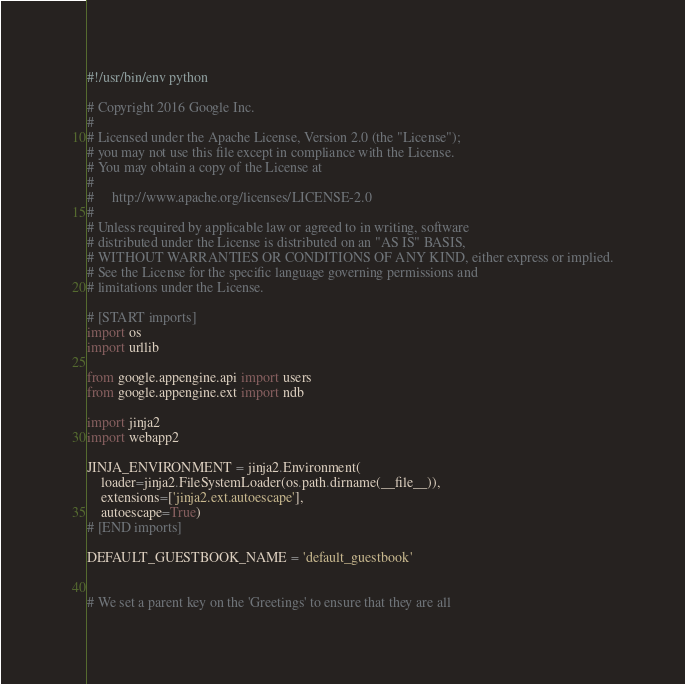Convert code to text. <code><loc_0><loc_0><loc_500><loc_500><_Python_>#!/usr/bin/env python

# Copyright 2016 Google Inc.
#
# Licensed under the Apache License, Version 2.0 (the "License");
# you may not use this file except in compliance with the License.
# You may obtain a copy of the License at
#
#     http://www.apache.org/licenses/LICENSE-2.0
#
# Unless required by applicable law or agreed to in writing, software
# distributed under the License is distributed on an "AS IS" BASIS,
# WITHOUT WARRANTIES OR CONDITIONS OF ANY KIND, either express or implied.
# See the License for the specific language governing permissions and
# limitations under the License.

# [START imports]
import os
import urllib

from google.appengine.api import users
from google.appengine.ext import ndb

import jinja2
import webapp2

JINJA_ENVIRONMENT = jinja2.Environment(
    loader=jinja2.FileSystemLoader(os.path.dirname(__file__)),
    extensions=['jinja2.ext.autoescape'],
    autoescape=True)
# [END imports]

DEFAULT_GUESTBOOK_NAME = 'default_guestbook'


# We set a parent key on the 'Greetings' to ensure that they are all</code> 